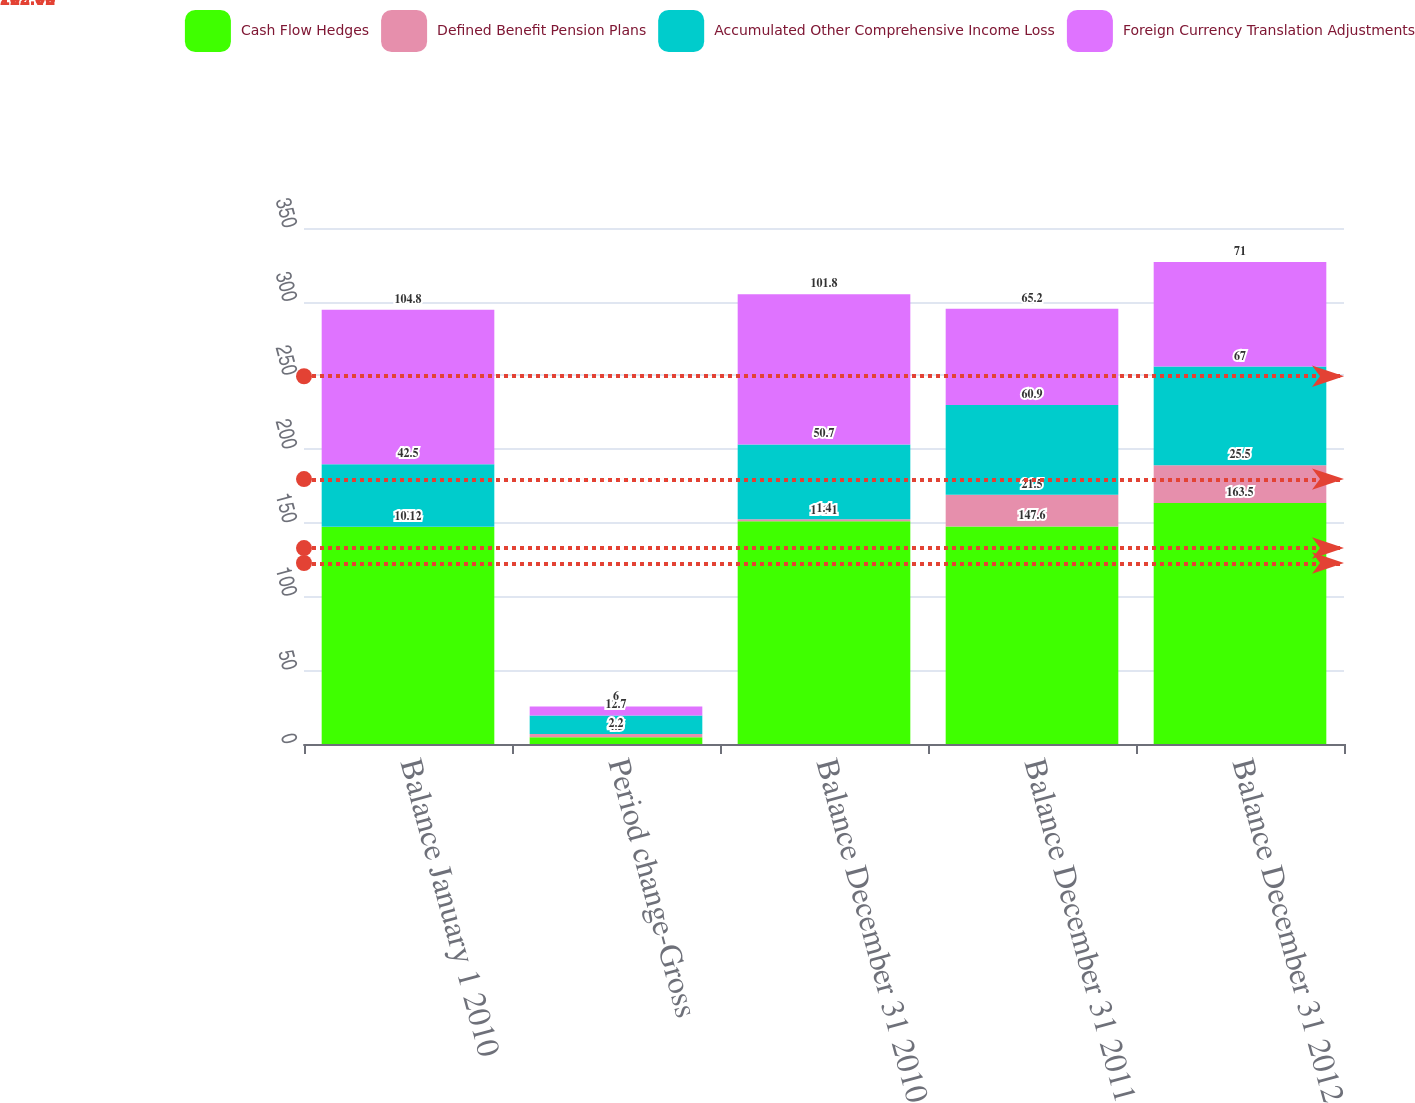Convert chart to OTSL. <chart><loc_0><loc_0><loc_500><loc_500><stacked_bar_chart><ecel><fcel>Balance January 1 2010<fcel>Period change-Gross<fcel>Balance December 31 2010<fcel>Balance December 31 2011<fcel>Balance December 31 2012<nl><fcel>Cash Flow Hedges<fcel>147.2<fcel>4.5<fcel>151.1<fcel>147.6<fcel>163.5<nl><fcel>Defined Benefit Pension Plans<fcel>0.1<fcel>2.2<fcel>1.4<fcel>21.5<fcel>25.5<nl><fcel>Accumulated Other Comprehensive Income Loss<fcel>42.5<fcel>12.7<fcel>50.7<fcel>60.9<fcel>67<nl><fcel>Foreign Currency Translation Adjustments<fcel>104.8<fcel>6<fcel>101.8<fcel>65.2<fcel>71<nl></chart> 